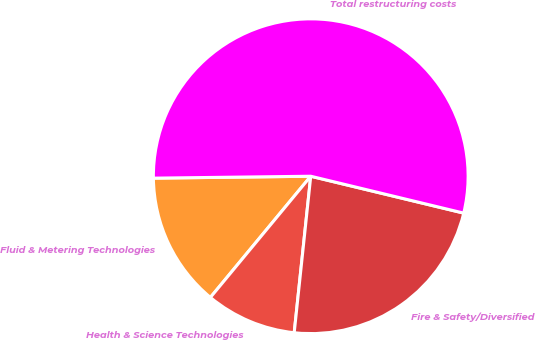<chart> <loc_0><loc_0><loc_500><loc_500><pie_chart><fcel>Fluid & Metering Technologies<fcel>Health & Science Technologies<fcel>Fire & Safety/Diversified<fcel>Total restructuring costs<nl><fcel>13.8%<fcel>9.33%<fcel>22.91%<fcel>53.96%<nl></chart> 